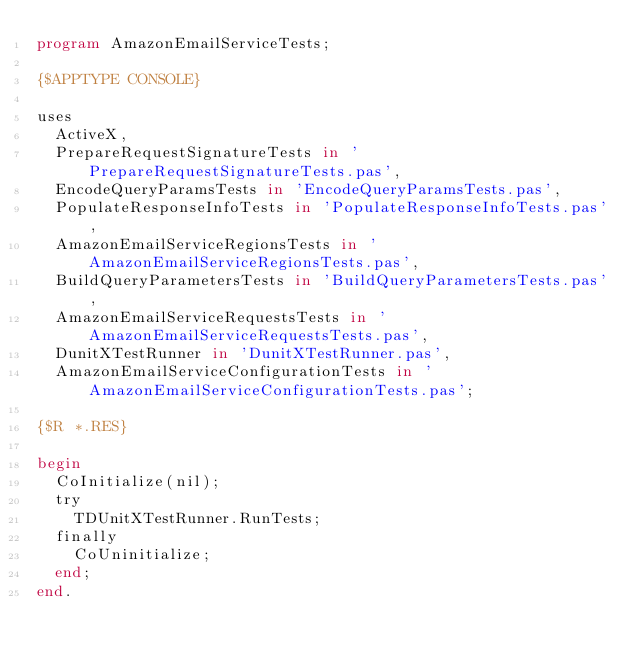Convert code to text. <code><loc_0><loc_0><loc_500><loc_500><_Pascal_>program AmazonEmailServiceTests;

{$APPTYPE CONSOLE}

uses
  ActiveX,
  PrepareRequestSignatureTests in 'PrepareRequestSignatureTests.pas',
  EncodeQueryParamsTests in 'EncodeQueryParamsTests.pas',
  PopulateResponseInfoTests in 'PopulateResponseInfoTests.pas',
  AmazonEmailServiceRegionsTests in 'AmazonEmailServiceRegionsTests.pas',
  BuildQueryParametersTests in 'BuildQueryParametersTests.pas',
  AmazonEmailServiceRequestsTests in 'AmazonEmailServiceRequestsTests.pas',
  DunitXTestRunner in 'DunitXTestRunner.pas',
  AmazonEmailServiceConfigurationTests in 'AmazonEmailServiceConfigurationTests.pas';

{$R *.RES}

begin
  CoInitialize(nil);
  try
    TDUnitXTestRunner.RunTests;
  finally
    CoUninitialize;
  end;
end.
</code> 